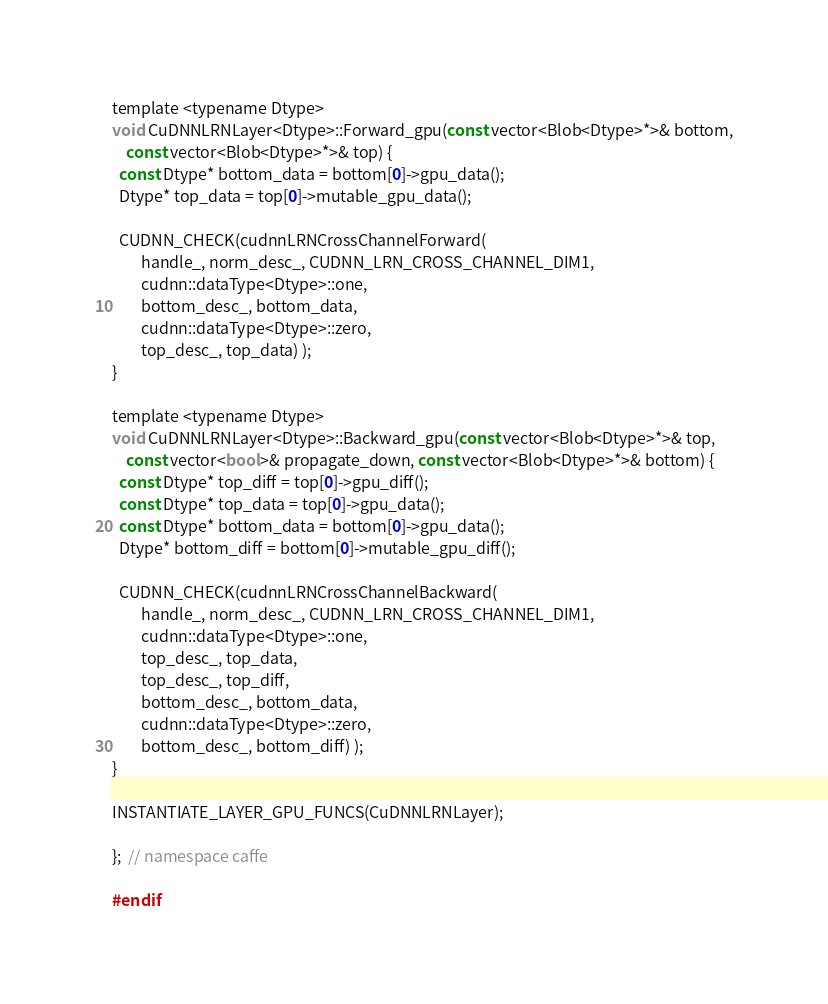Convert code to text. <code><loc_0><loc_0><loc_500><loc_500><_Cuda_>template <typename Dtype>
void CuDNNLRNLayer<Dtype>::Forward_gpu(const vector<Blob<Dtype>*>& bottom,
    const vector<Blob<Dtype>*>& top) {
  const Dtype* bottom_data = bottom[0]->gpu_data();
  Dtype* top_data = top[0]->mutable_gpu_data();

  CUDNN_CHECK(cudnnLRNCrossChannelForward(
        handle_, norm_desc_, CUDNN_LRN_CROSS_CHANNEL_DIM1,
        cudnn::dataType<Dtype>::one,
        bottom_desc_, bottom_data,
        cudnn::dataType<Dtype>::zero,
        top_desc_, top_data) );
}

template <typename Dtype>
void CuDNNLRNLayer<Dtype>::Backward_gpu(const vector<Blob<Dtype>*>& top,
    const vector<bool>& propagate_down, const vector<Blob<Dtype>*>& bottom) {
  const Dtype* top_diff = top[0]->gpu_diff();
  const Dtype* top_data = top[0]->gpu_data();
  const Dtype* bottom_data = bottom[0]->gpu_data();
  Dtype* bottom_diff = bottom[0]->mutable_gpu_diff();

  CUDNN_CHECK(cudnnLRNCrossChannelBackward(
        handle_, norm_desc_, CUDNN_LRN_CROSS_CHANNEL_DIM1,
        cudnn::dataType<Dtype>::one,
        top_desc_, top_data,
        top_desc_, top_diff,
        bottom_desc_, bottom_data,
        cudnn::dataType<Dtype>::zero,
        bottom_desc_, bottom_diff) );
}

INSTANTIATE_LAYER_GPU_FUNCS(CuDNNLRNLayer);

};  // namespace caffe

#endif
</code> 